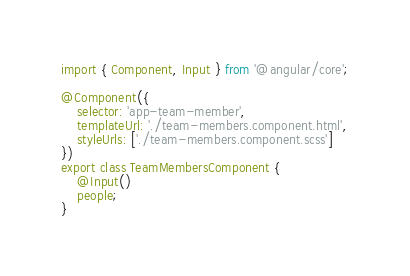<code> <loc_0><loc_0><loc_500><loc_500><_TypeScript_>import { Component, Input } from '@angular/core';

@Component({
    selector: 'app-team-member',
    templateUrl: './team-members.component.html',
    styleUrls: ['./team-members.component.scss']
})
export class TeamMembersComponent {
    @Input()
    people;
}
</code> 